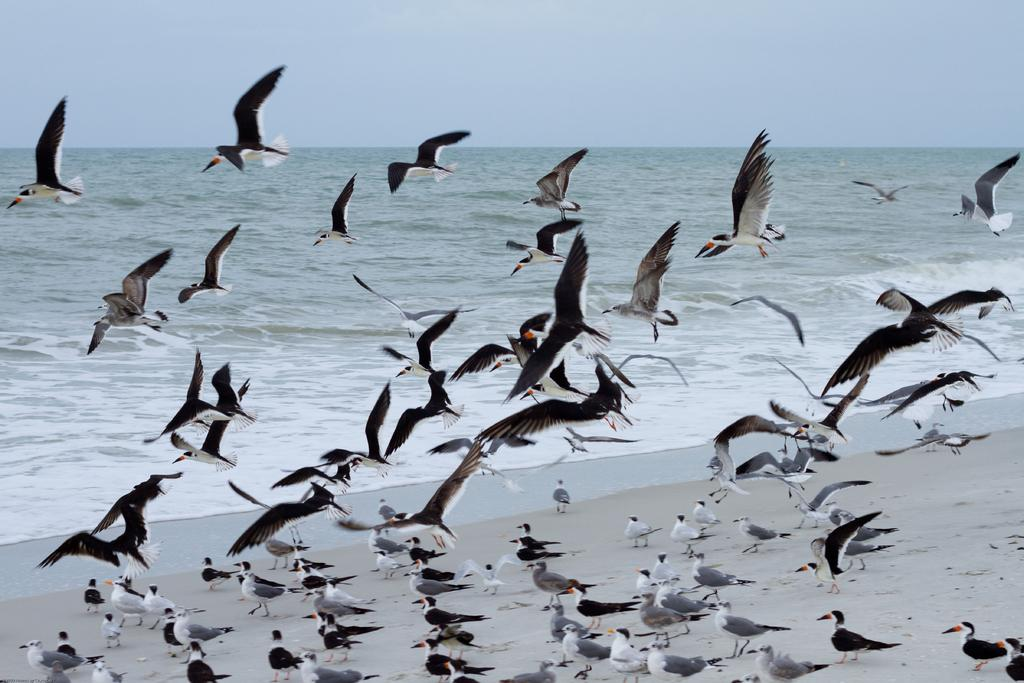What type of animals can be seen in the image? Birds can be seen in the image, both in the air and on the land. What is visible in the background of the image? There is an ocean in the background of the image. What part of the natural environment is visible at the top of the image? The sky is visible at the top of the image. How many cherries can be seen on the birds in the image? There are no cherries present in the image; it features birds in the air and on the land. Can you describe the sound of the birds cracking open nuts in the image? There is no sound or indication of birds cracking open nuts in the image. 